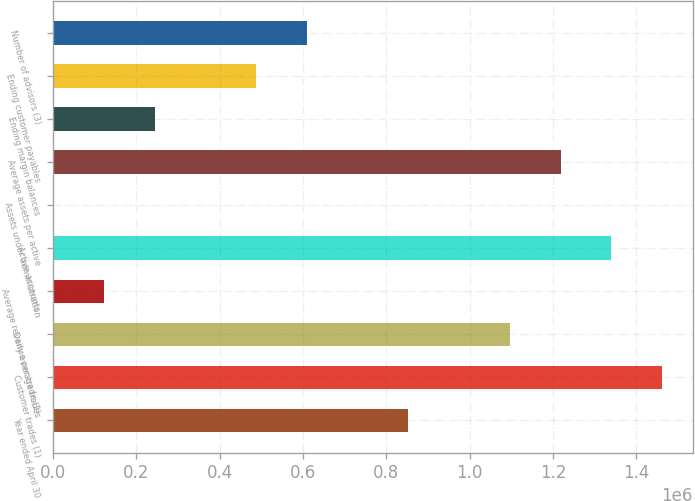Convert chart. <chart><loc_0><loc_0><loc_500><loc_500><bar_chart><fcel>Year ended April 30<fcel>Customer trades (1)<fcel>Daily average trades<fcel>Average revenue per trade (2)<fcel>Active accounts<fcel>Assets under administration<fcel>Average assets per active<fcel>Ending margin balances<fcel>Ending customer payables<fcel>Number of advisors (3)<nl><fcel>852671<fcel>1.46171e+06<fcel>1.09629e+06<fcel>121829<fcel>1.3399e+06<fcel>22.3<fcel>1.21809e+06<fcel>243636<fcel>487250<fcel>609057<nl></chart> 